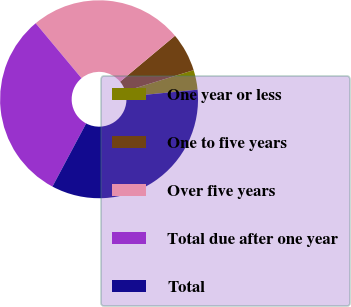Convert chart. <chart><loc_0><loc_0><loc_500><loc_500><pie_chart><fcel>One year or less<fcel>One to five years<fcel>Over five years<fcel>Total due after one year<fcel>Total<nl><fcel>3.21%<fcel>6.33%<fcel>24.98%<fcel>31.13%<fcel>34.35%<nl></chart> 